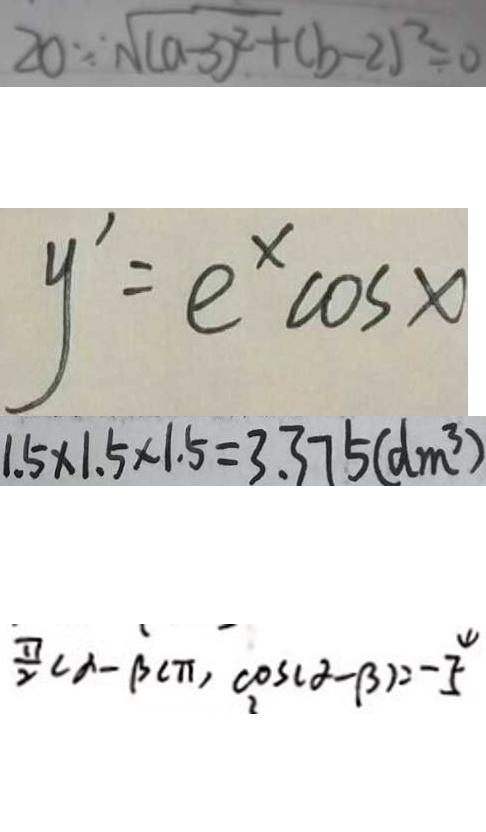<formula> <loc_0><loc_0><loc_500><loc_500>2 0 \because \sqrt { ( a - 3 ) ^ { 2 } } + ( b - 2 ) ^ { 2 } = 0 
 y ^ { \prime } = e ^ { x } \cos x 
 1 . 5 \times 1 . 5 \times 1 . 5 = 3 . 3 7 5 ( d m ^ { 3 } ) 
 \frac { \pi } { 2 } c \alpha - \beta c \pi , \cos ( \alpha - \beta ) = - \frac { 4 } { 5 }</formula> 